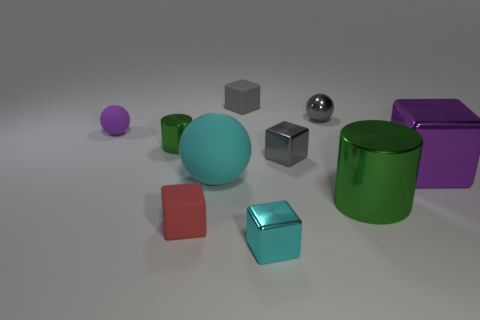What is the size of the red rubber block?
Give a very brief answer. Small. Is the number of small purple matte objects that are in front of the red rubber thing less than the number of tiny green objects?
Ensure brevity in your answer.  Yes. Do the purple rubber thing and the gray rubber block have the same size?
Provide a succinct answer. Yes. Are there any other things that are the same size as the cyan metallic thing?
Offer a terse response. Yes. The small cylinder that is the same material as the large purple thing is what color?
Your answer should be very brief. Green. Are there fewer metal cylinders behind the purple block than tiny green objects behind the gray matte block?
Make the answer very short. No. What number of small objects have the same color as the big matte ball?
Provide a short and direct response. 1. What material is the small cube that is the same color as the large ball?
Keep it short and to the point. Metal. What number of tiny metal things are both to the left of the big rubber sphere and behind the tiny metal cylinder?
Ensure brevity in your answer.  0. What is the gray block that is in front of the gray matte cube that is to the right of the red thing made of?
Keep it short and to the point. Metal. 